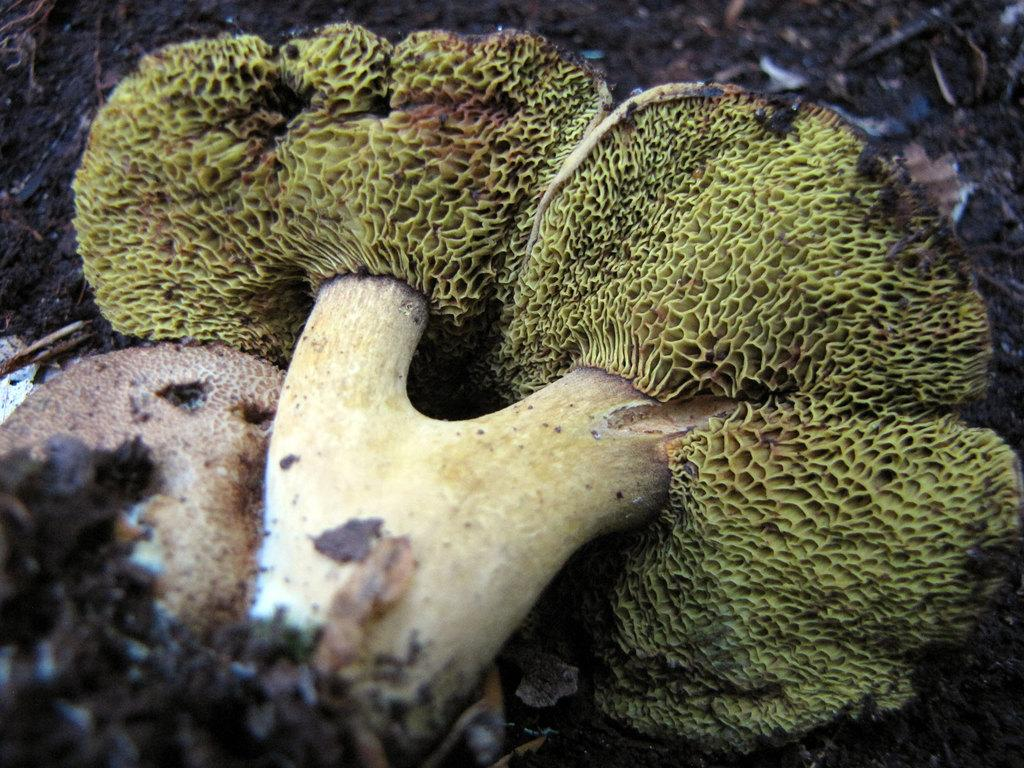What type of organisms can be seen in the image? There are mushrooms and fungus in the image. Can you describe the appearance of the mushrooms? The provided facts do not include a description of the mushrooms' appearance. How many oranges are present on the cactus in the image? There is no cactus or oranges present in the image; it features mushrooms and fungus. What time of day is depicted in the image? The provided facts do not include information about the time of day depicted in the image. 